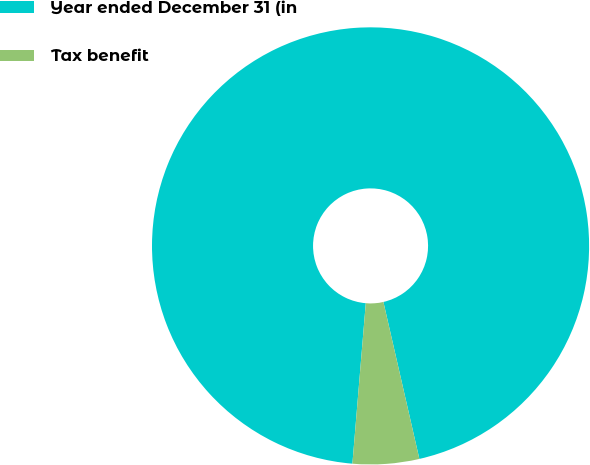Convert chart. <chart><loc_0><loc_0><loc_500><loc_500><pie_chart><fcel>Year ended December 31 (in<fcel>Tax benefit<nl><fcel>95.09%<fcel>4.91%<nl></chart> 